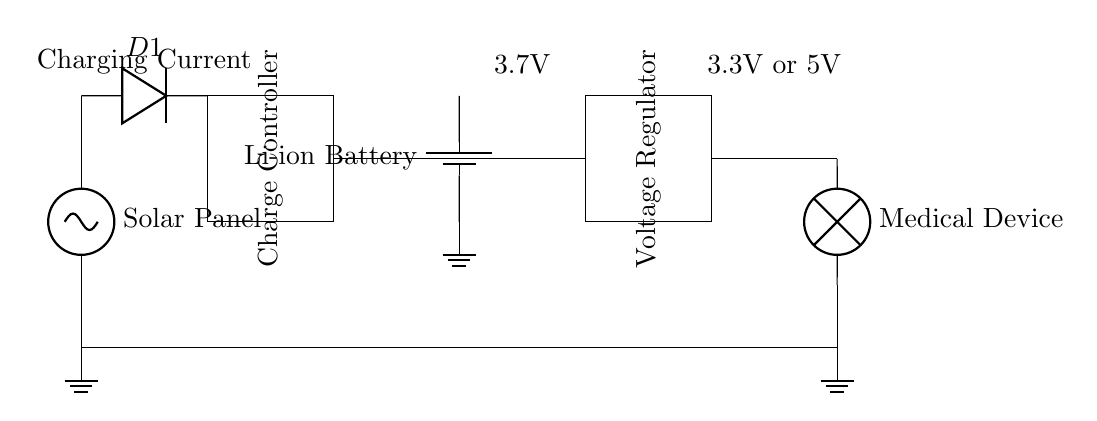What is the main power source for this circuit? The main power source is the solar panel, which provides voltage to charge the battery.
Answer: Solar Panel What component is responsible for preventing reverse current? The diode, named D1 in the circuit, allows current to flow only in one direction, thus preventing reverse current.
Answer: Diode What is the purpose of the charge controller? The charge controller regulates the charging of the battery, ensuring it is charged properly and safely to extend its life.
Answer: Charge Controller What is the output voltage after the voltage regulator? The output voltage is either 3.3V or 5V, as indicated at the output side of the regulator in the diagram.
Answer: 3.3V or 5V How does the battery connect to the rest of the circuit? The battery is connected to the charge controller, which takes the charging current from the solar panel and sends it to the battery to charge it.
Answer: Charge Controller Why is a voltage regulator used in this circuit? The voltage regulator is used to ensure that the voltage supplied to medical devices is consistent and within the required range, either 3.3V or 5V, regardless of variations in supply from the battery.
Answer: Voltage Regulator What type of battery is used in this circuit? A lithium-ion battery is specified in the circuit diagram, which is common for storing energy in small devices due to its high energy density.
Answer: Li-ion Battery 